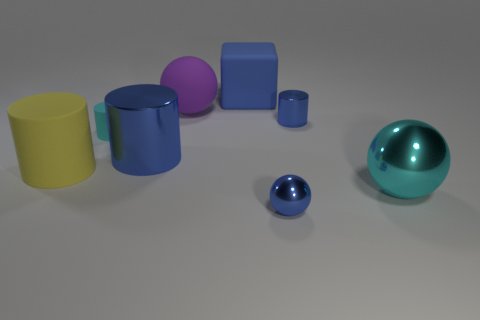Subtract all green cubes. Subtract all purple cylinders. How many cubes are left? 1 Subtract all yellow cylinders. How many blue spheres are left? 1 Add 1 tiny cyans. How many blues exist? 0 Subtract all small yellow metallic cylinders. Subtract all cyan cylinders. How many objects are left? 7 Add 6 big yellow cylinders. How many big yellow cylinders are left? 7 Add 4 small purple metallic balls. How many small purple metallic balls exist? 4 Add 2 yellow cylinders. How many objects exist? 10 Subtract all yellow cylinders. How many cylinders are left? 3 Subtract all big rubber cylinders. How many cylinders are left? 3 Subtract 0 brown cubes. How many objects are left? 8 